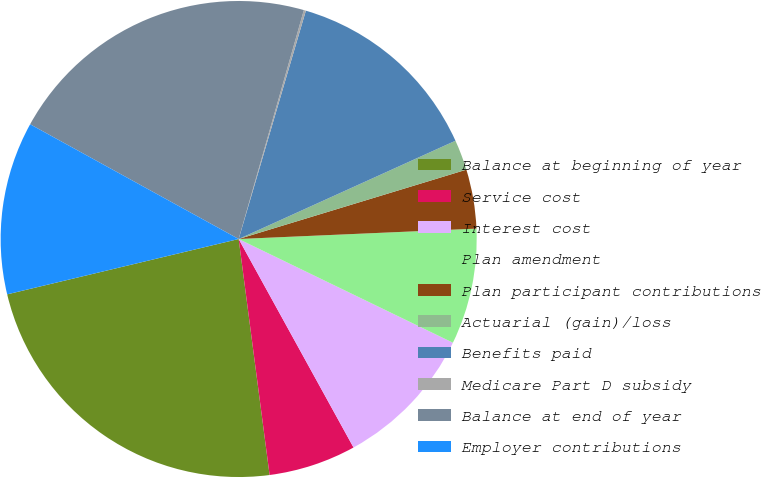Convert chart to OTSL. <chart><loc_0><loc_0><loc_500><loc_500><pie_chart><fcel>Balance at beginning of year<fcel>Service cost<fcel>Interest cost<fcel>Plan amendment<fcel>Plan participant contributions<fcel>Actuarial (gain)/loss<fcel>Benefits paid<fcel>Medicare Part D subsidy<fcel>Balance at end of year<fcel>Employer contributions<nl><fcel>23.34%<fcel>5.94%<fcel>9.81%<fcel>7.87%<fcel>4.01%<fcel>2.07%<fcel>13.67%<fcel>0.14%<fcel>21.41%<fcel>11.74%<nl></chart> 